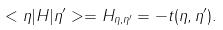<formula> <loc_0><loc_0><loc_500><loc_500>< \eta | H | \eta ^ { \prime } > = H _ { \eta , \eta ^ { \prime } } = - t ( \eta , \eta ^ { \prime } ) .</formula> 